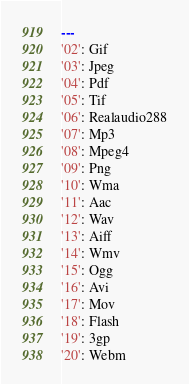Convert code to text. <code><loc_0><loc_0><loc_500><loc_500><_YAML_>---
'02': Gif
'03': Jpeg
'04': Pdf
'05': Tif
'06': Realaudio288
'07': Mp3
'08': Mpeg4
'09': Png
'10': Wma
'11': Aac
'12': Wav
'13': Aiff
'14': Wmv
'15': Ogg
'16': Avi
'17': Mov
'18': Flash
'19': 3gp
'20': Webm
</code> 